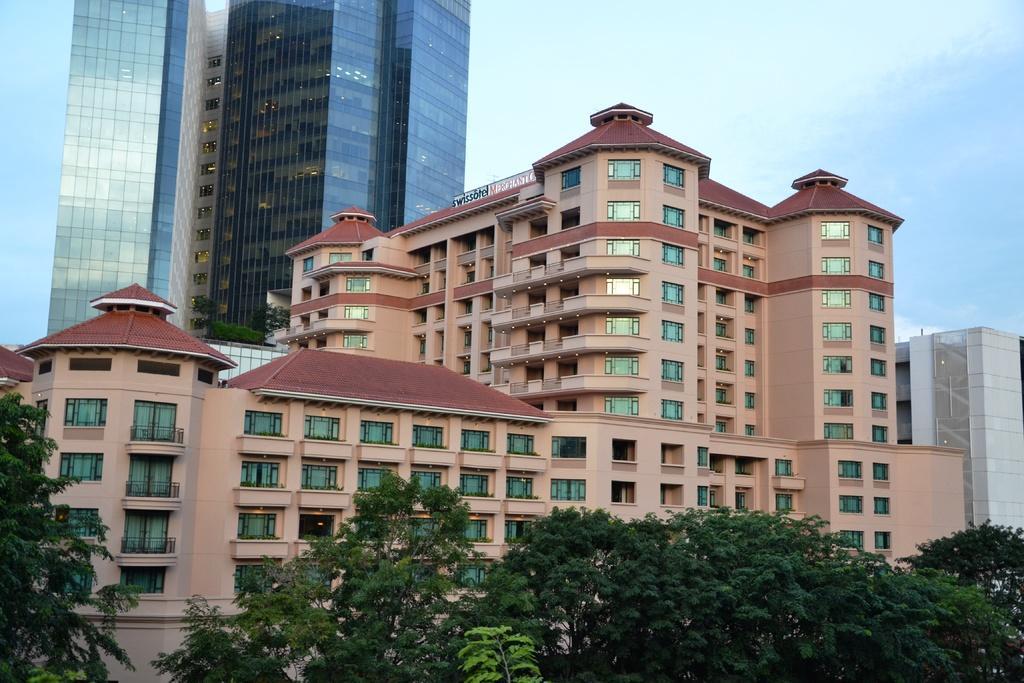Please provide a concise description of this image. In this image we can see a group of buildings with windows. We can also see a signboard with some text on it, a group of trees, some plants and the sky which looks cloudy. 